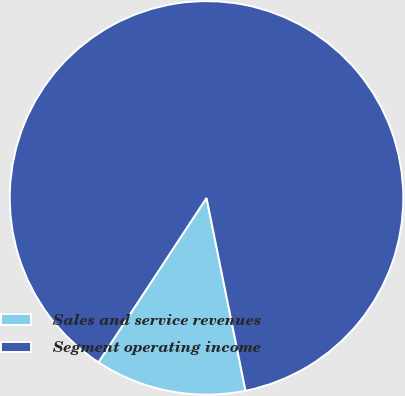Convert chart. <chart><loc_0><loc_0><loc_500><loc_500><pie_chart><fcel>Sales and service revenues<fcel>Segment operating income<nl><fcel>12.43%<fcel>87.57%<nl></chart> 